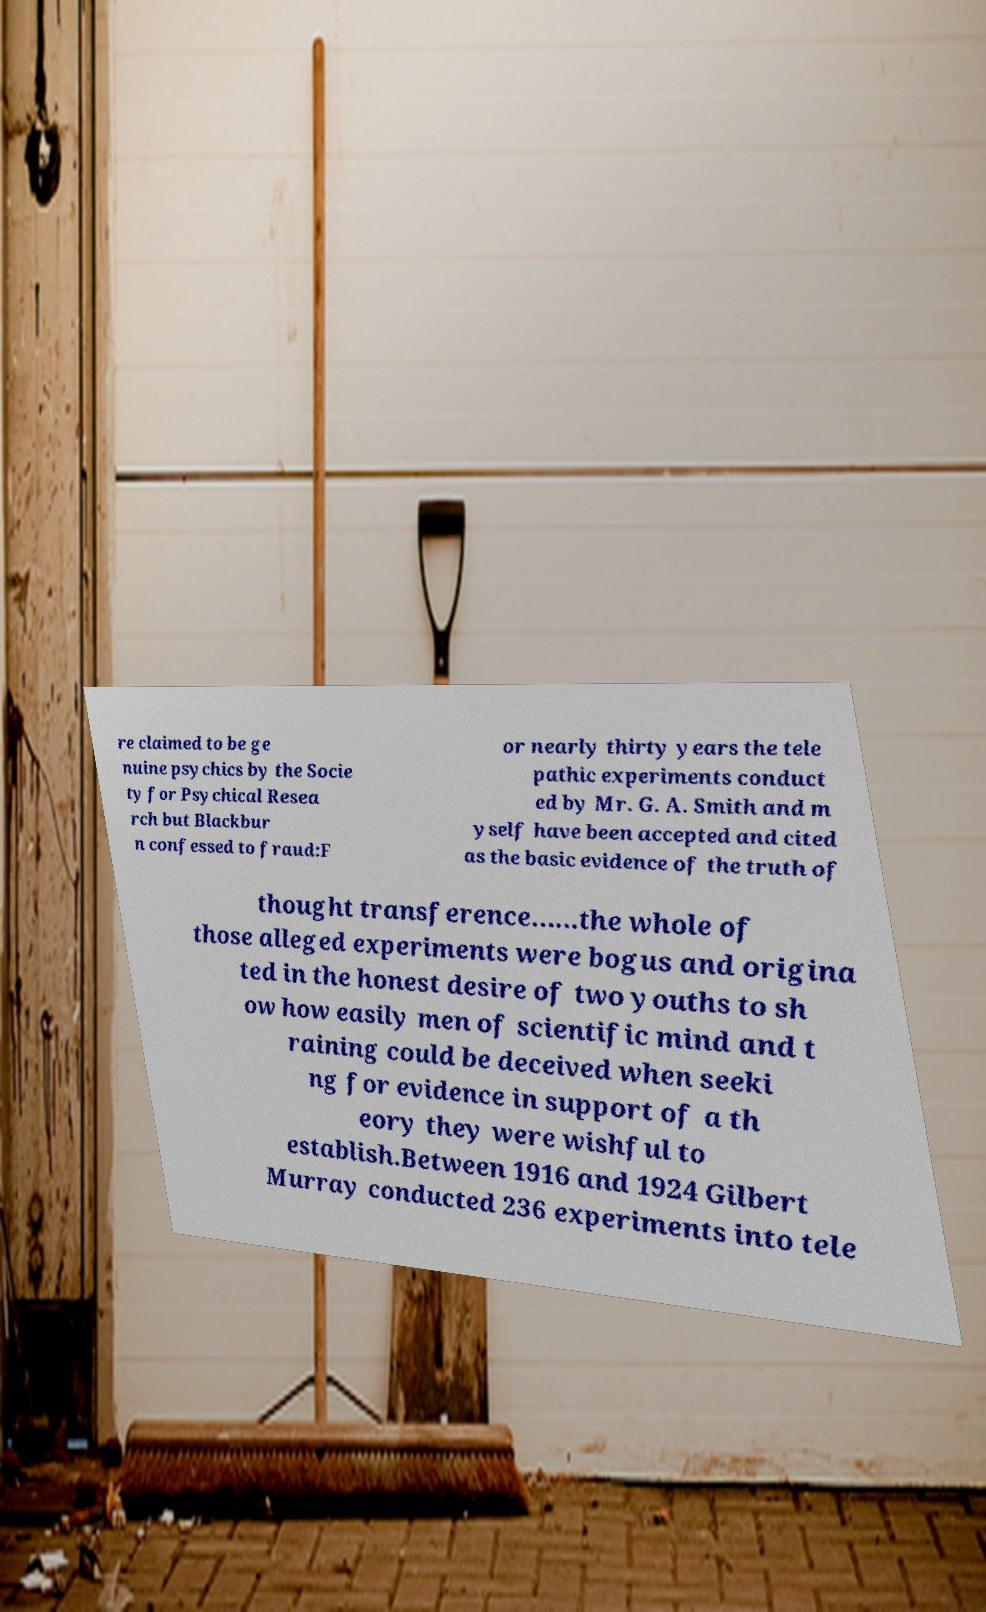Please read and relay the text visible in this image. What does it say? re claimed to be ge nuine psychics by the Socie ty for Psychical Resea rch but Blackbur n confessed to fraud:F or nearly thirty years the tele pathic experiments conduct ed by Mr. G. A. Smith and m yself have been accepted and cited as the basic evidence of the truth of thought transference......the whole of those alleged experiments were bogus and origina ted in the honest desire of two youths to sh ow how easily men of scientific mind and t raining could be deceived when seeki ng for evidence in support of a th eory they were wishful to establish.Between 1916 and 1924 Gilbert Murray conducted 236 experiments into tele 